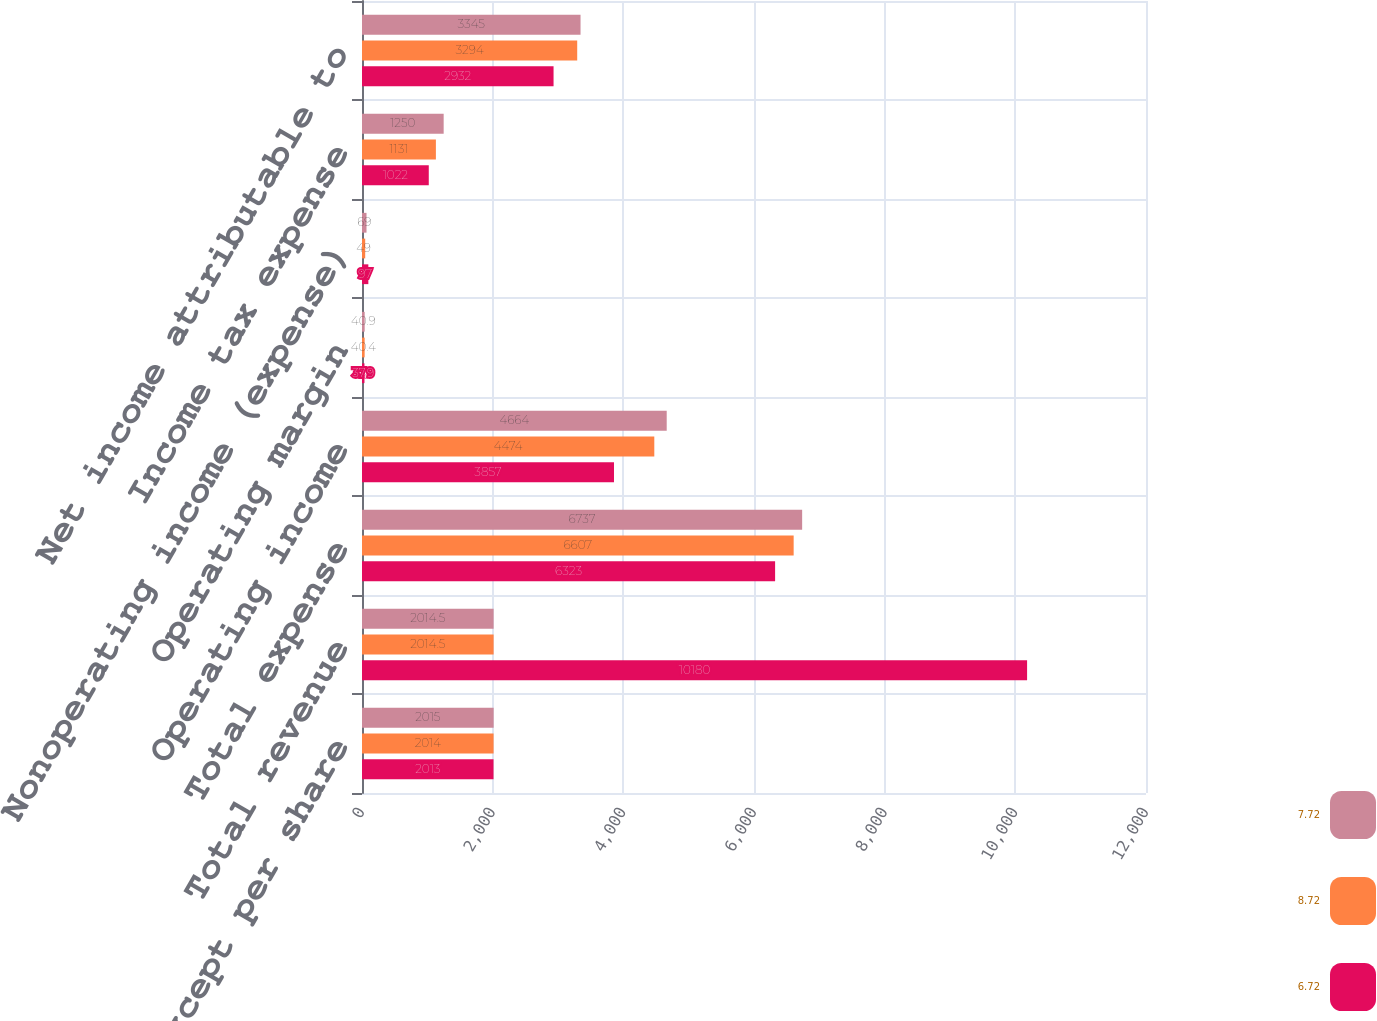<chart> <loc_0><loc_0><loc_500><loc_500><stacked_bar_chart><ecel><fcel>(in millions except per share<fcel>Total revenue<fcel>Total expense<fcel>Operating income<fcel>Operating margin<fcel>Nonoperating income (expense)<fcel>Income tax expense<fcel>Net income attributable to<nl><fcel>7.72<fcel>2015<fcel>2014.5<fcel>6737<fcel>4664<fcel>40.9<fcel>69<fcel>1250<fcel>3345<nl><fcel>8.72<fcel>2014<fcel>2014.5<fcel>6607<fcel>4474<fcel>40.4<fcel>49<fcel>1131<fcel>3294<nl><fcel>6.72<fcel>2013<fcel>10180<fcel>6323<fcel>3857<fcel>37.9<fcel>97<fcel>1022<fcel>2932<nl></chart> 